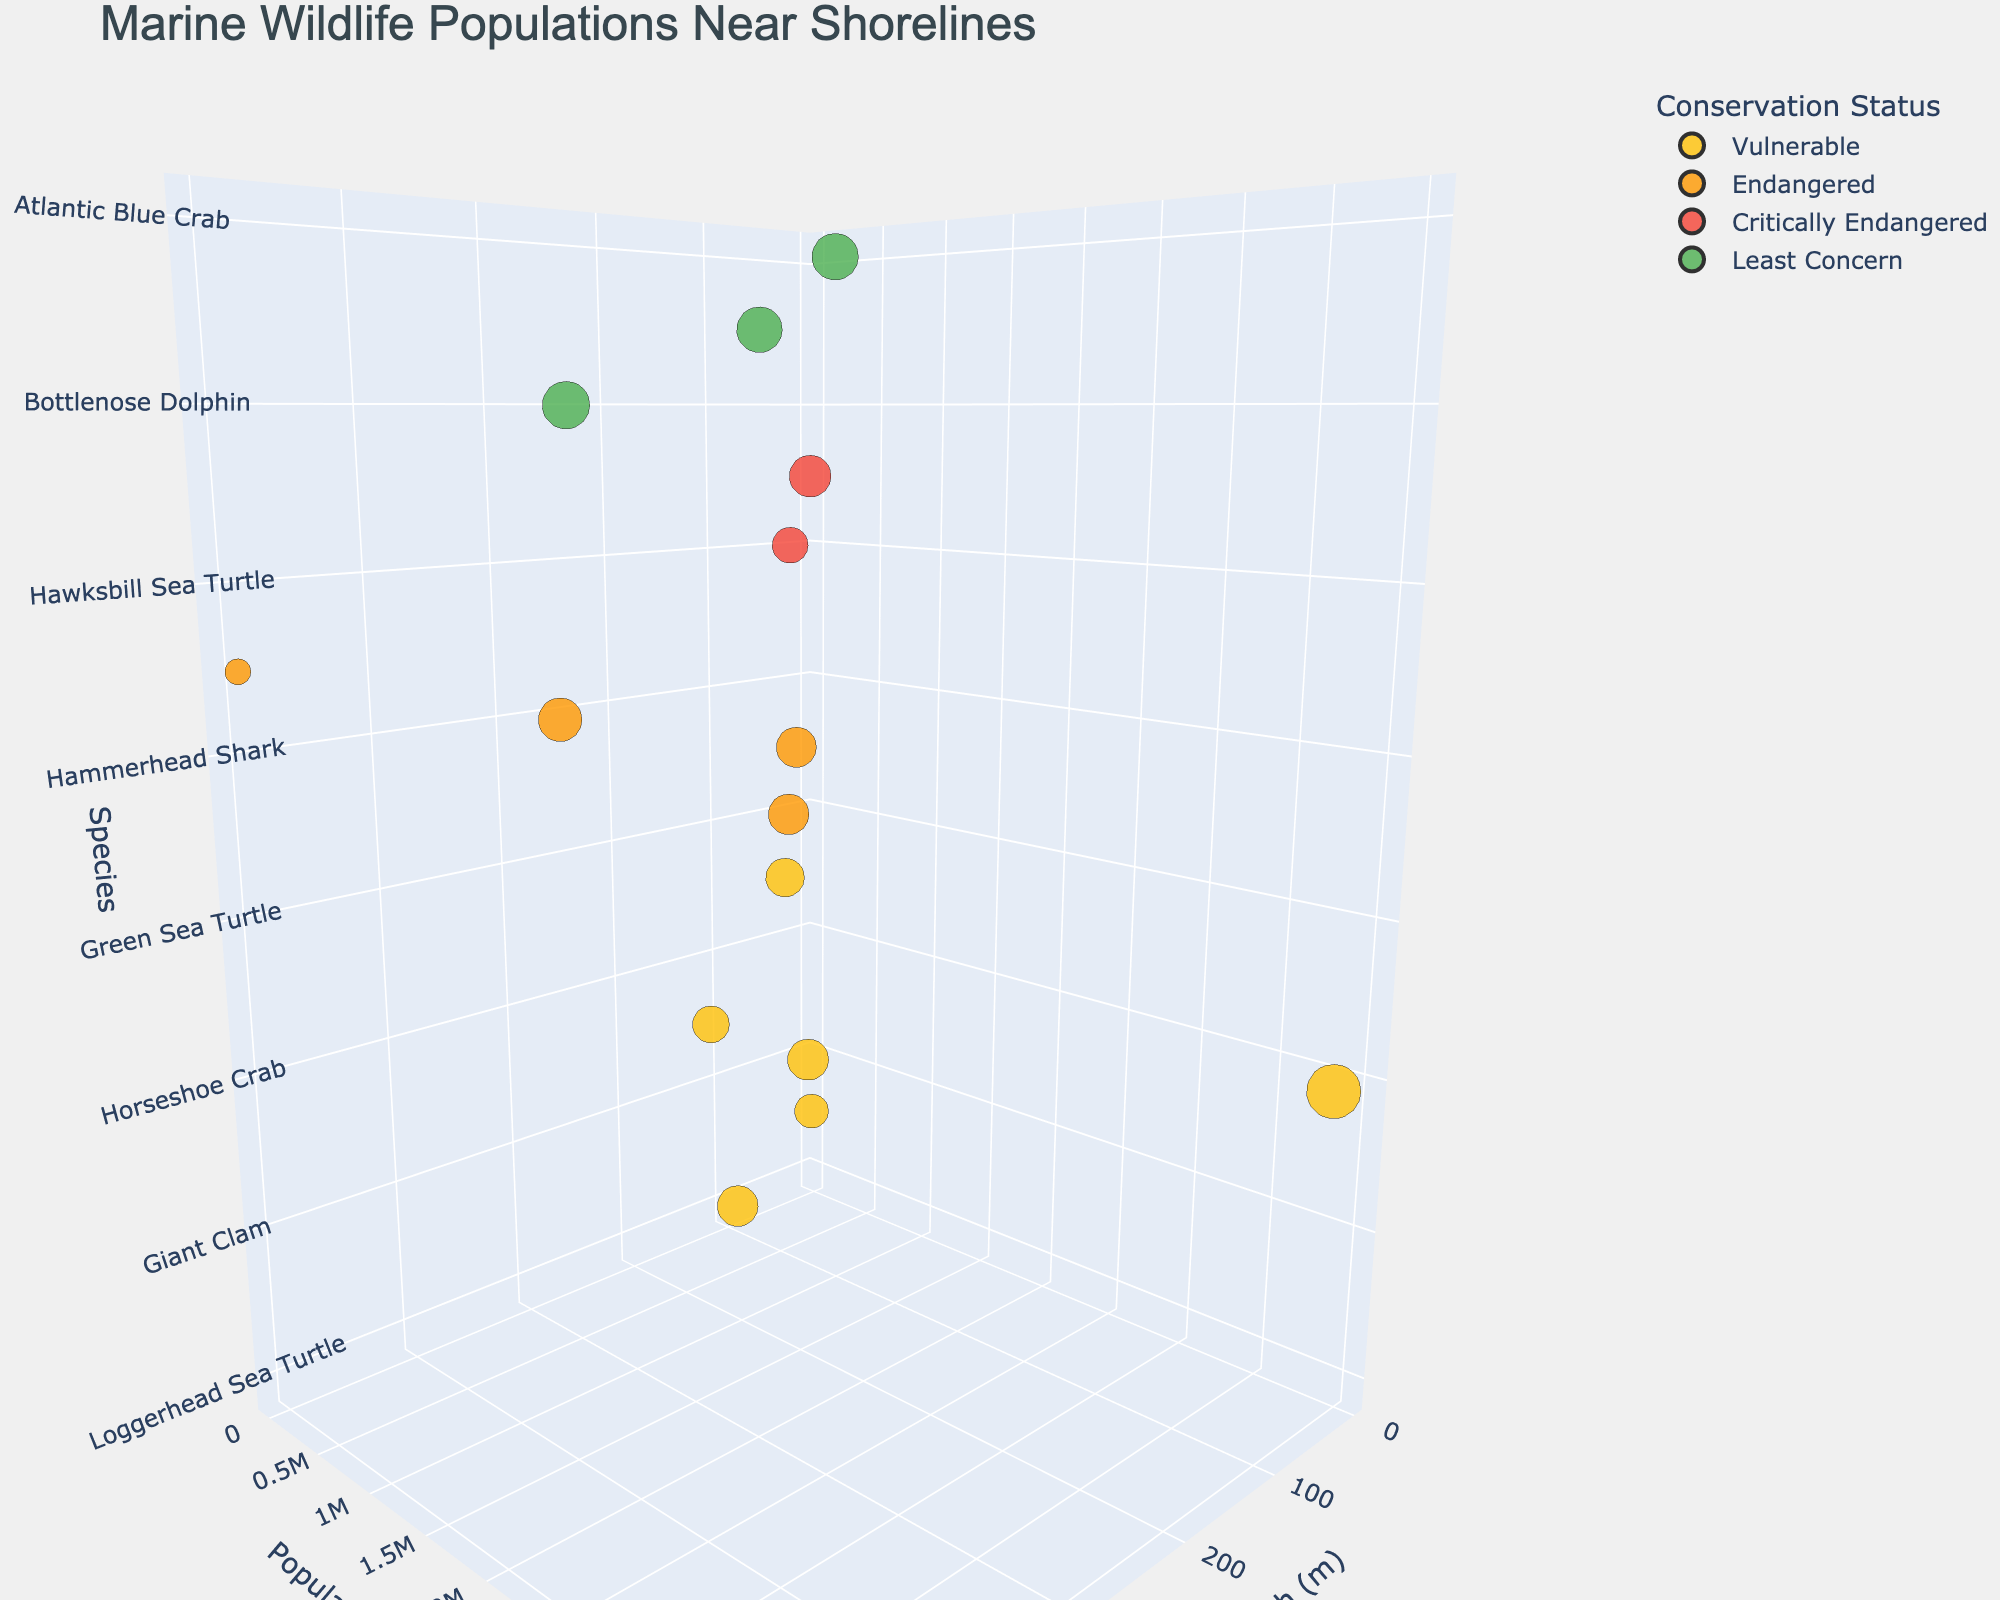What is the title of the figure? The title is usually displayed at the top of the figure. The title in this chart is "Marine Wildlife Populations Near Shorelines".
Answer: Marine Wildlife Populations Near Shorelines How many species are marked as Critically Endangered? Look for the species represented by the color corresponding to "Critically Endangered" in the legend. There are two species: Hawksbill Sea Turtle and Coral Staghorn.
Answer: 2 Which species has the highest population estimate? From the y-axis "Population Estimate," find the species with the highest value. The Horseshoe Crab has the highest estimation.
Answer: Horseshoe Crab What is the habitat depth range for Green Sea Turtles? Look at the z-axis labeled "Species" to find Green Sea Turtles and check their x-axis values for "Habitat Depth". The Green Sea Turtle's habitat depth range is 0-40 meters.
Answer: 0-40 meters What is the average population estimate of the Loggerhead Sea Turtle, Green Sea Turtle, and Hawksbill Sea Turtle? Find the population estimates for these species, then calculate their average: (90000 + 85000 + 23000) / 3.
Answer: 66000 Which species in the "Least Concern" category has the smallest population estimate? In the legend, identify species under "Least Concern" and compare their population estimates. The Harbor Seal has the smallest population estimate among them.
Answer: Harbor Seal What is the median habitat depth of all listed species? Extract all habitat depth ranges, convert them to midpoints ((start+end)/2), then determine the median value: (100+40+30+300+1005+15+30+20+120+275+35+30+40+500)/14 = (10 + 20 + 20 + 32.5 + 52.5 + 67.5 + 60 + 100 + 100 + 150 + 167.5 + 187.5 + 150 + 272.5)/14. Median is 45.
Answer: 45 meters Compare the population estimates of the Endangered species and identify the one with the highest estimate. Find all species with "Endangered" status and compare their population estimates: Green Sea Turtle (85000), Queen Conch (75000), Hammerhead Shark (200000), Monk Seal (1400). Hammerhead Shark has the highest estimate.
Answer: Hammerhead Shark What is the ratio of the highest population estimate to the lowest population estimate in the dataset? Identify the highest and lowest population estimates: Horseshoe Crab (4000000) and Monk Seal (1400). Calculate the ratio: 4000000 / 1400.
Answer: 2857.14 Which conservation status category has the most species? Count the species in each conservation status category from the legend: Least Concern (3), Vulnerable (5), Endangered (4), Critically Endangered (2). Vulnerable has the most species.
Answer: Vulnerable 